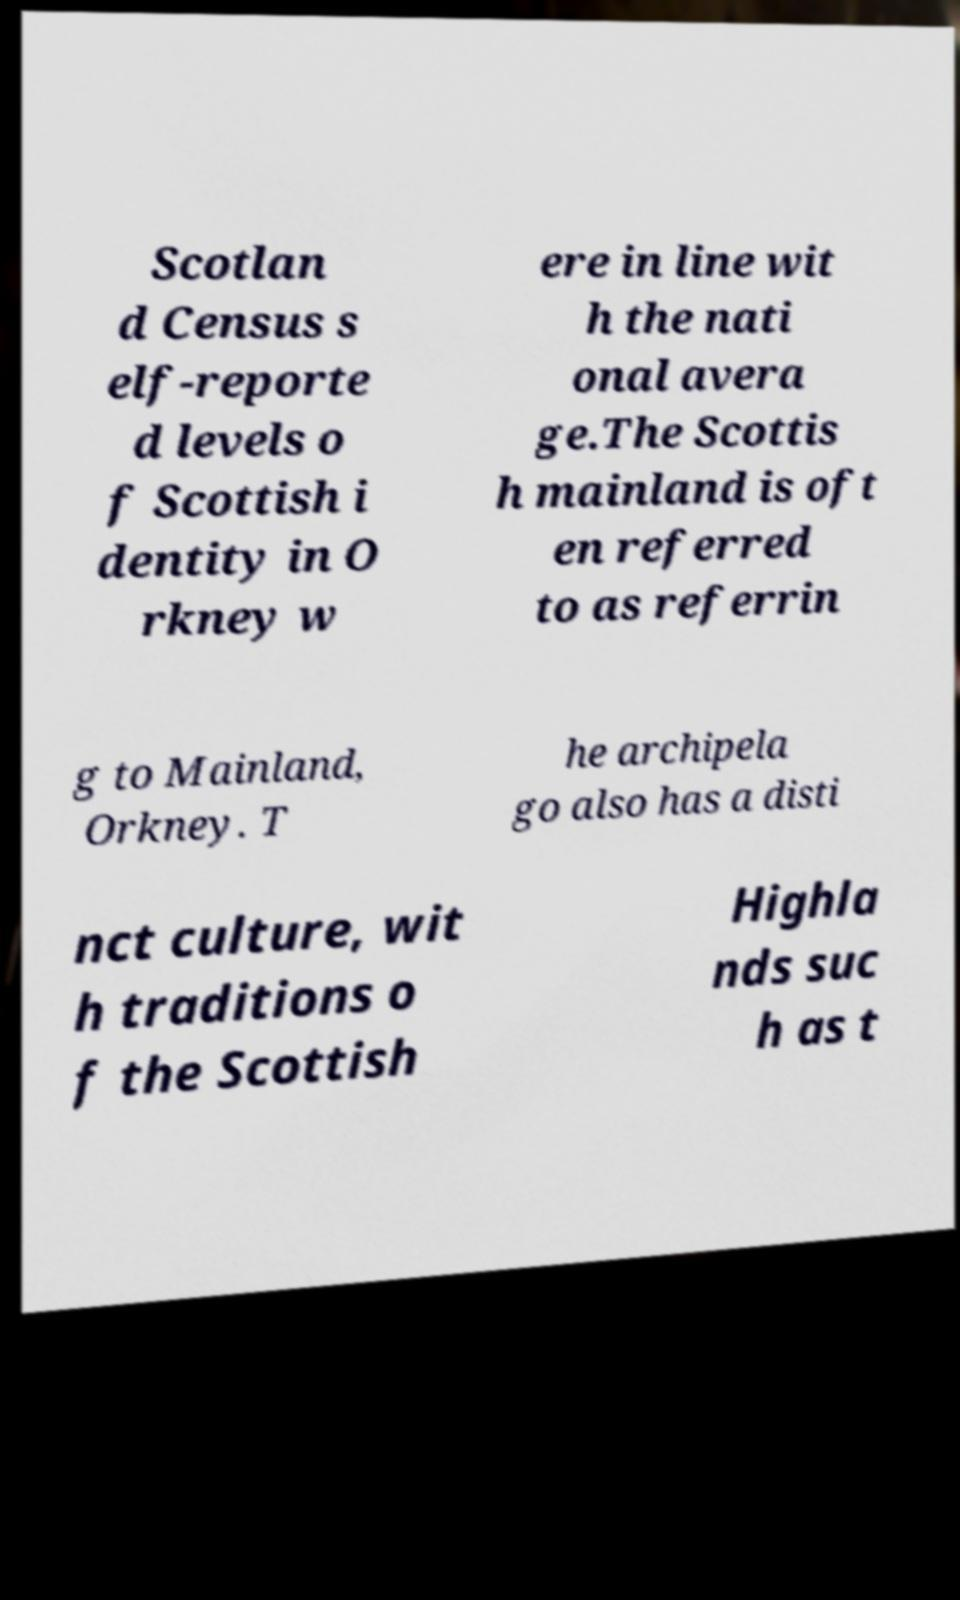Can you accurately transcribe the text from the provided image for me? Scotlan d Census s elf-reporte d levels o f Scottish i dentity in O rkney w ere in line wit h the nati onal avera ge.The Scottis h mainland is oft en referred to as referrin g to Mainland, Orkney. T he archipela go also has a disti nct culture, wit h traditions o f the Scottish Highla nds suc h as t 